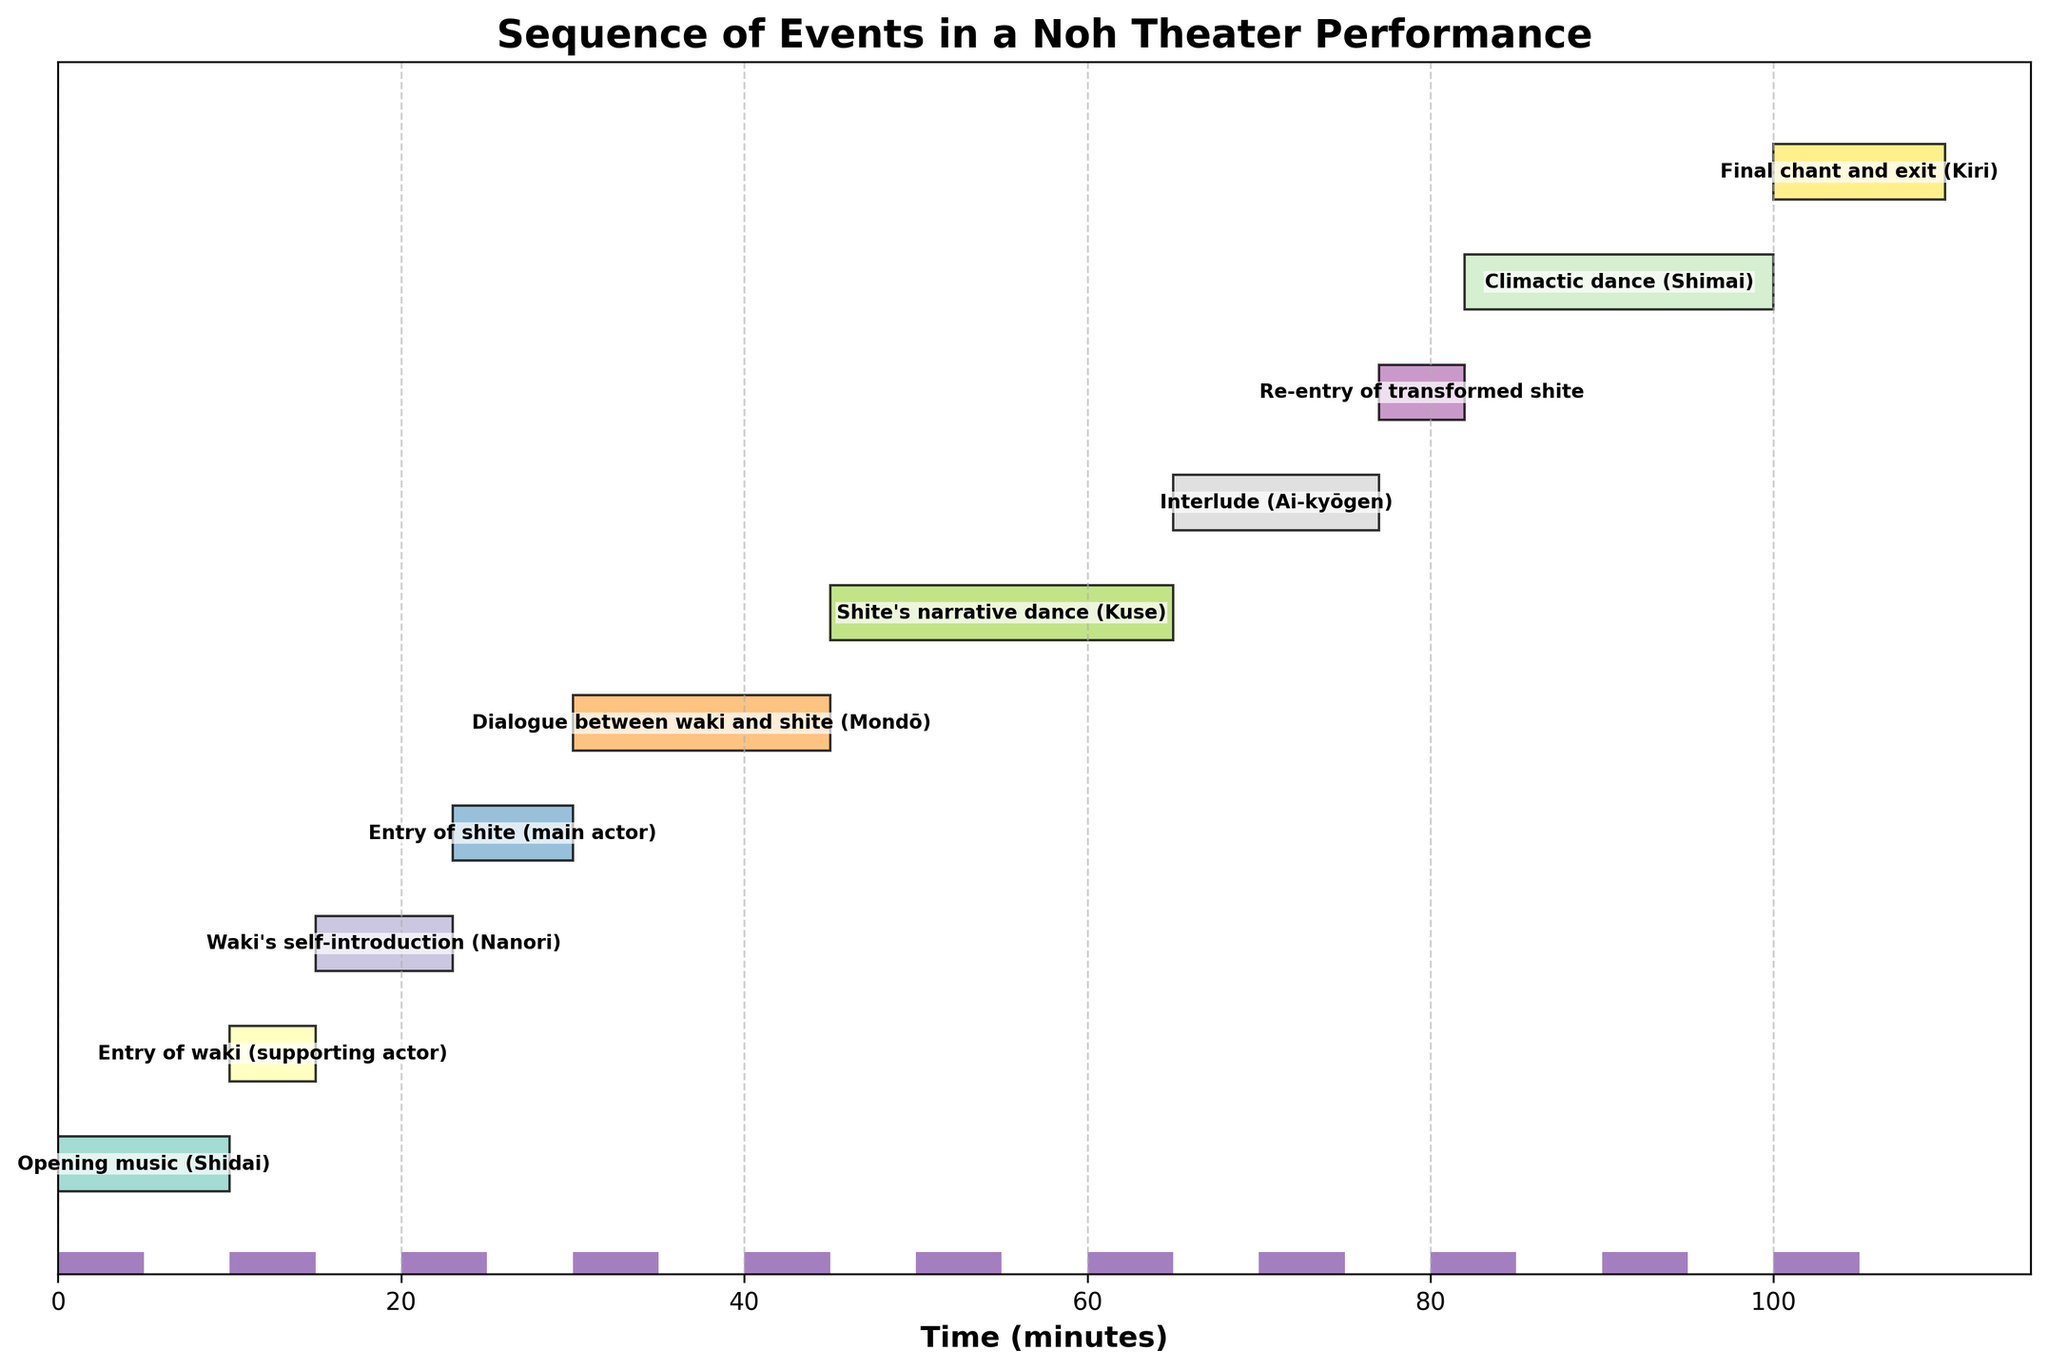what is the duration of the opening music (Shidai)? The duration can be read directly from the bar representing the "Opening music (Shidai)" on the Gantt chart, which shows a length of 10 minutes.
Answer: 10 minutes At what time does the Waki's self-introduction (Nanori) start? The start time can be read directly from the beginning of the corresponding bar, which is at 15 minutes.
Answer: 15 minutes Which event has the longest duration in the performance? By comparing the lengths of all the bars, we see that "Shite's narrative dance (Kuse)" has the longest duration of 20 minutes.
Answer: Shite's narrative dance (Kuse) What is the total duration from the start of the opening music to the end of the final chant and exit (Kiri)? Adding the start time of the "Opening music (Shidai)" (0) to its duration (10), we get to its end at 10 minutes. Then we continue summing up the durations till "Final chant and exit (Kiri)", which ends at 110 minutes.
Answer: 110 minutes When does the climactic dance (Shimai) occur in the sequence? Referencing the Gantt chart, we see that "Climactic dance (Shimai)" starts at 82 minutes and ends at 100 minutes.
Answer: 82 minutes Between which two events does the interlude (Ai-kyōgen) occur? The Gantt chart shows it starts after "Shite's narrative dance (Kuse)" (65 minutes) and ends before "Re-entry of transformed shite" (77 minutes).
Answer: After Shite's narrative dance, before Re-entry of transformed shite Which event has a duration twice as long as the entry of shite (main actor)? The duration of "Entry of shite" is 7 minutes. Checking other events, "Dialogue between waki and shite (Mondō)" at 15 minutes fits this criteria.
Answer: Dialogue between waki and shite (Mondō) How much time passes between the entry of waki and the re-entry of transformed shite? Calculate from the end of the "Entry of waki" (15 minutes) to the start of "Re-entry of transformed shite" (77 minutes), making it a difference of 62 minutes.
Answer: 62 minutes Which event starts immediately after the dialogue between waki and shite (Mondō)? Consult the Gantt chart, where "Shite's narrative dance (Kuse)" starts exactly after "Dialogue between waki and shite".
Answer: Shite's narrative dance (Kuse) What is the combined duration of all events involving the main actor (shite)? Summing the durations of "Entry of shite" (7), "Dialogue between waki and shite" (15), "Shite's narrative dance" (20), "Re-entry of transformed shite" (5), "Climactic dance" (18) gives 65 minutes.
Answer: 65 minutes 